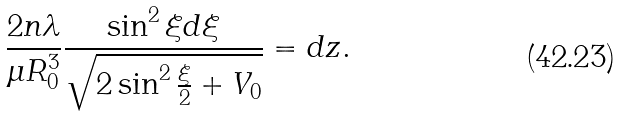<formula> <loc_0><loc_0><loc_500><loc_500>\frac { 2 n \lambda } { \mu R _ { 0 } ^ { 3 } } \frac { \sin ^ { 2 } \xi d \xi } { \sqrt { 2 \sin ^ { 2 } \frac { \xi } { 2 } + V _ { 0 } } } = d z .</formula> 